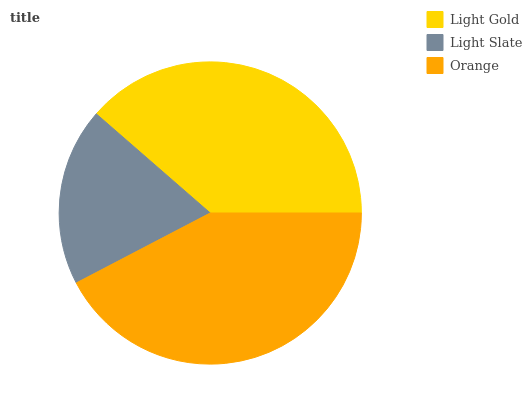Is Light Slate the minimum?
Answer yes or no. Yes. Is Orange the maximum?
Answer yes or no. Yes. Is Orange the minimum?
Answer yes or no. No. Is Light Slate the maximum?
Answer yes or no. No. Is Orange greater than Light Slate?
Answer yes or no. Yes. Is Light Slate less than Orange?
Answer yes or no. Yes. Is Light Slate greater than Orange?
Answer yes or no. No. Is Orange less than Light Slate?
Answer yes or no. No. Is Light Gold the high median?
Answer yes or no. Yes. Is Light Gold the low median?
Answer yes or no. Yes. Is Orange the high median?
Answer yes or no. No. Is Orange the low median?
Answer yes or no. No. 